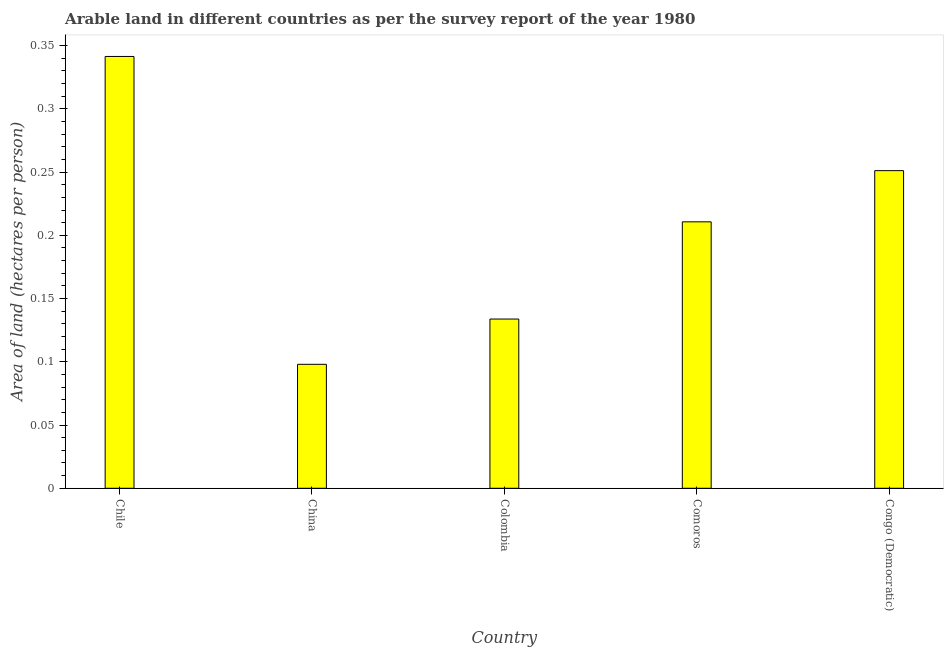What is the title of the graph?
Your response must be concise. Arable land in different countries as per the survey report of the year 1980. What is the label or title of the Y-axis?
Your response must be concise. Area of land (hectares per person). What is the area of arable land in Chile?
Provide a succinct answer. 0.34. Across all countries, what is the maximum area of arable land?
Your answer should be very brief. 0.34. Across all countries, what is the minimum area of arable land?
Ensure brevity in your answer.  0.1. What is the sum of the area of arable land?
Ensure brevity in your answer.  1.04. What is the difference between the area of arable land in Comoros and Congo (Democratic)?
Offer a terse response. -0.04. What is the average area of arable land per country?
Ensure brevity in your answer.  0.21. What is the median area of arable land?
Ensure brevity in your answer.  0.21. What is the ratio of the area of arable land in China to that in Congo (Democratic)?
Your answer should be compact. 0.39. Is the area of arable land in Chile less than that in China?
Offer a very short reply. No. What is the difference between the highest and the second highest area of arable land?
Offer a terse response. 0.09. Is the sum of the area of arable land in Chile and Colombia greater than the maximum area of arable land across all countries?
Your answer should be very brief. Yes. What is the difference between the highest and the lowest area of arable land?
Offer a terse response. 0.24. In how many countries, is the area of arable land greater than the average area of arable land taken over all countries?
Your response must be concise. 3. How many bars are there?
Keep it short and to the point. 5. How many countries are there in the graph?
Provide a short and direct response. 5. Are the values on the major ticks of Y-axis written in scientific E-notation?
Your answer should be compact. No. What is the Area of land (hectares per person) in Chile?
Offer a terse response. 0.34. What is the Area of land (hectares per person) of China?
Your response must be concise. 0.1. What is the Area of land (hectares per person) in Colombia?
Provide a succinct answer. 0.13. What is the Area of land (hectares per person) in Comoros?
Offer a very short reply. 0.21. What is the Area of land (hectares per person) of Congo (Democratic)?
Give a very brief answer. 0.25. What is the difference between the Area of land (hectares per person) in Chile and China?
Give a very brief answer. 0.24. What is the difference between the Area of land (hectares per person) in Chile and Colombia?
Provide a succinct answer. 0.21. What is the difference between the Area of land (hectares per person) in Chile and Comoros?
Your response must be concise. 0.13. What is the difference between the Area of land (hectares per person) in Chile and Congo (Democratic)?
Make the answer very short. 0.09. What is the difference between the Area of land (hectares per person) in China and Colombia?
Make the answer very short. -0.04. What is the difference between the Area of land (hectares per person) in China and Comoros?
Your response must be concise. -0.11. What is the difference between the Area of land (hectares per person) in China and Congo (Democratic)?
Your response must be concise. -0.15. What is the difference between the Area of land (hectares per person) in Colombia and Comoros?
Make the answer very short. -0.08. What is the difference between the Area of land (hectares per person) in Colombia and Congo (Democratic)?
Your response must be concise. -0.12. What is the difference between the Area of land (hectares per person) in Comoros and Congo (Democratic)?
Offer a terse response. -0.04. What is the ratio of the Area of land (hectares per person) in Chile to that in China?
Keep it short and to the point. 3.48. What is the ratio of the Area of land (hectares per person) in Chile to that in Colombia?
Offer a terse response. 2.55. What is the ratio of the Area of land (hectares per person) in Chile to that in Comoros?
Make the answer very short. 1.62. What is the ratio of the Area of land (hectares per person) in Chile to that in Congo (Democratic)?
Your answer should be compact. 1.36. What is the ratio of the Area of land (hectares per person) in China to that in Colombia?
Your answer should be very brief. 0.73. What is the ratio of the Area of land (hectares per person) in China to that in Comoros?
Offer a very short reply. 0.47. What is the ratio of the Area of land (hectares per person) in China to that in Congo (Democratic)?
Offer a terse response. 0.39. What is the ratio of the Area of land (hectares per person) in Colombia to that in Comoros?
Make the answer very short. 0.64. What is the ratio of the Area of land (hectares per person) in Colombia to that in Congo (Democratic)?
Provide a succinct answer. 0.53. What is the ratio of the Area of land (hectares per person) in Comoros to that in Congo (Democratic)?
Provide a succinct answer. 0.84. 